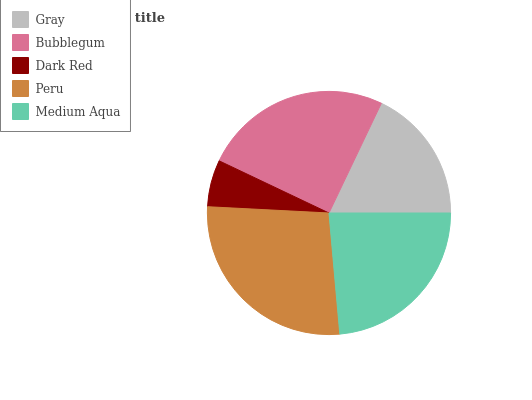Is Dark Red the minimum?
Answer yes or no. Yes. Is Peru the maximum?
Answer yes or no. Yes. Is Bubblegum the minimum?
Answer yes or no. No. Is Bubblegum the maximum?
Answer yes or no. No. Is Bubblegum greater than Gray?
Answer yes or no. Yes. Is Gray less than Bubblegum?
Answer yes or no. Yes. Is Gray greater than Bubblegum?
Answer yes or no. No. Is Bubblegum less than Gray?
Answer yes or no. No. Is Medium Aqua the high median?
Answer yes or no. Yes. Is Medium Aqua the low median?
Answer yes or no. Yes. Is Gray the high median?
Answer yes or no. No. Is Gray the low median?
Answer yes or no. No. 